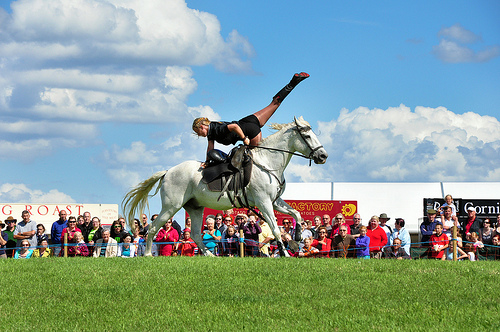<image>
Can you confirm if the woman is to the left of the horse? No. The woman is not to the left of the horse. From this viewpoint, they have a different horizontal relationship. Is there a man behind the horse? Yes. From this viewpoint, the man is positioned behind the horse, with the horse partially or fully occluding the man. Is there a horse in front of the people? Yes. The horse is positioned in front of the people, appearing closer to the camera viewpoint. Is there a horse in front of the cloud? No. The horse is not in front of the cloud. The spatial positioning shows a different relationship between these objects. 